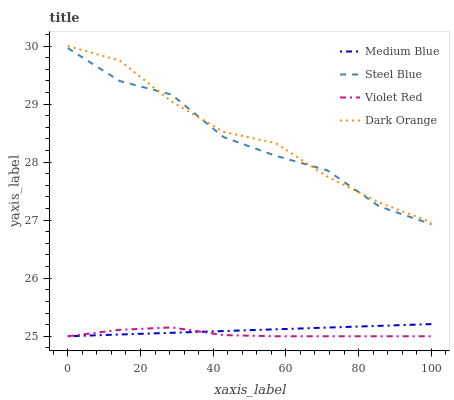Does Violet Red have the minimum area under the curve?
Answer yes or no. Yes. Does Dark Orange have the maximum area under the curve?
Answer yes or no. Yes. Does Medium Blue have the minimum area under the curve?
Answer yes or no. No. Does Medium Blue have the maximum area under the curve?
Answer yes or no. No. Is Medium Blue the smoothest?
Answer yes or no. Yes. Is Steel Blue the roughest?
Answer yes or no. Yes. Is Violet Red the smoothest?
Answer yes or no. No. Is Violet Red the roughest?
Answer yes or no. No. Does Violet Red have the lowest value?
Answer yes or no. Yes. Does Steel Blue have the lowest value?
Answer yes or no. No. Does Dark Orange have the highest value?
Answer yes or no. Yes. Does Medium Blue have the highest value?
Answer yes or no. No. Is Medium Blue less than Steel Blue?
Answer yes or no. Yes. Is Steel Blue greater than Medium Blue?
Answer yes or no. Yes. Does Dark Orange intersect Steel Blue?
Answer yes or no. Yes. Is Dark Orange less than Steel Blue?
Answer yes or no. No. Is Dark Orange greater than Steel Blue?
Answer yes or no. No. Does Medium Blue intersect Steel Blue?
Answer yes or no. No. 